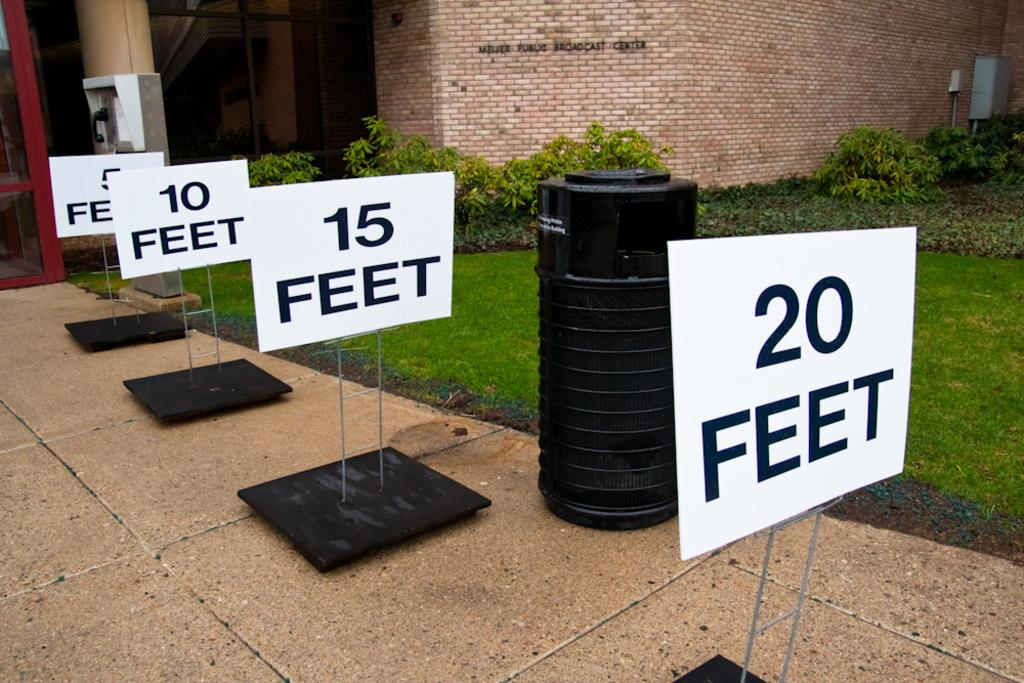<image>
Share a concise interpretation of the image provided. White sign which says 20 feet away in black letters. 